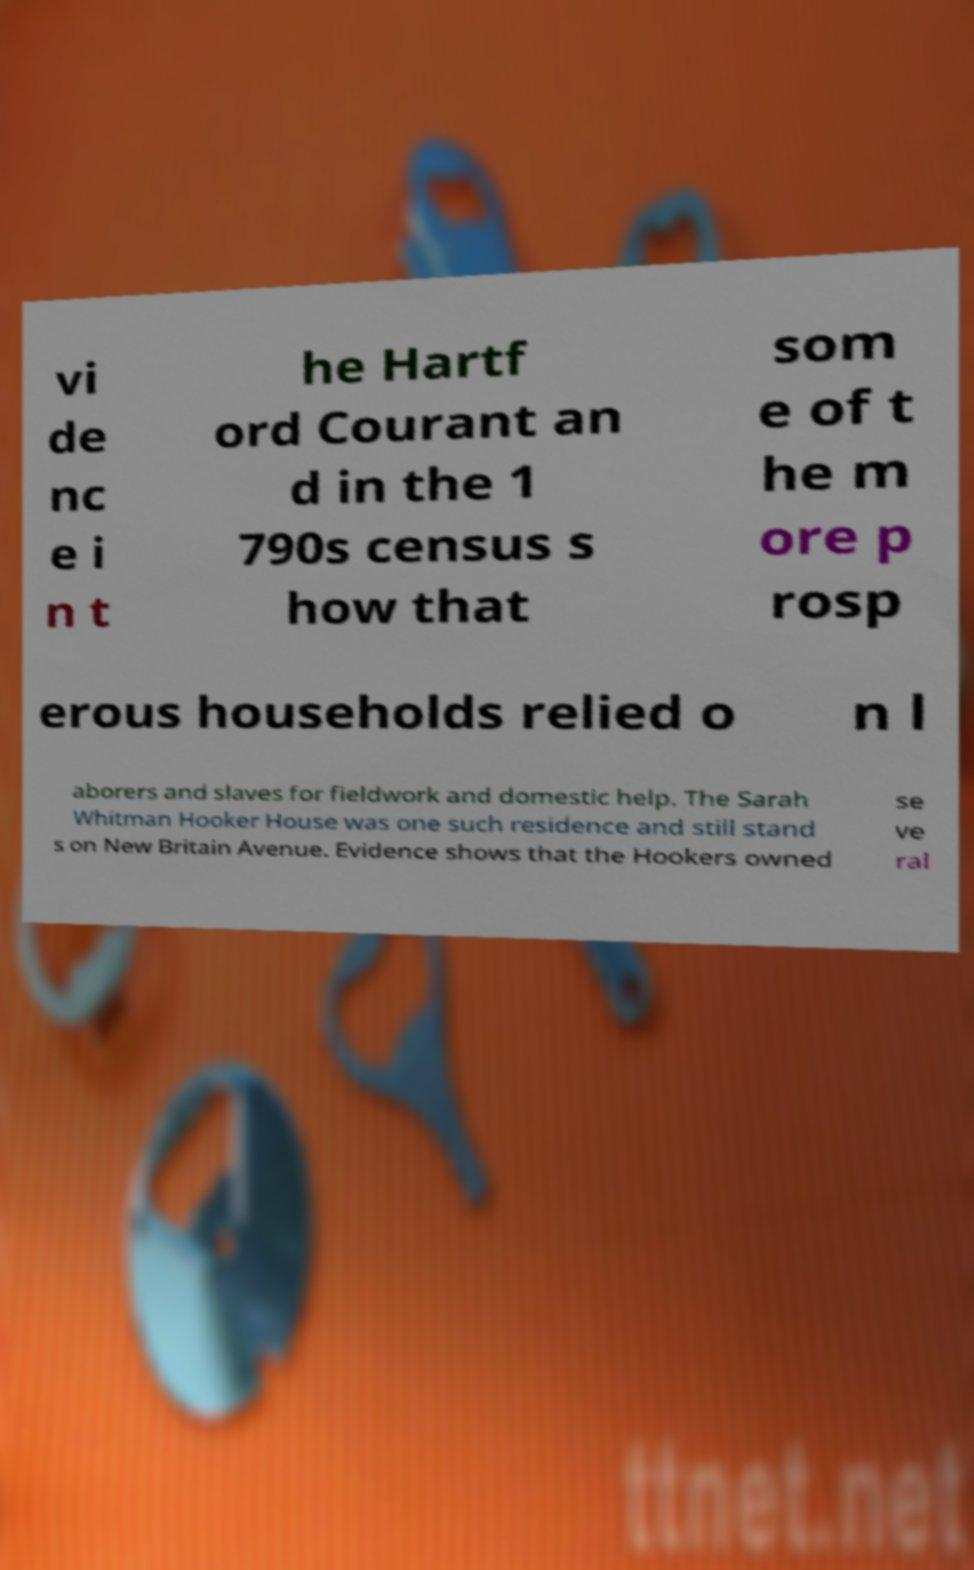Can you accurately transcribe the text from the provided image for me? vi de nc e i n t he Hartf ord Courant an d in the 1 790s census s how that som e of t he m ore p rosp erous households relied o n l aborers and slaves for fieldwork and domestic help. The Sarah Whitman Hooker House was one such residence and still stand s on New Britain Avenue. Evidence shows that the Hookers owned se ve ral 